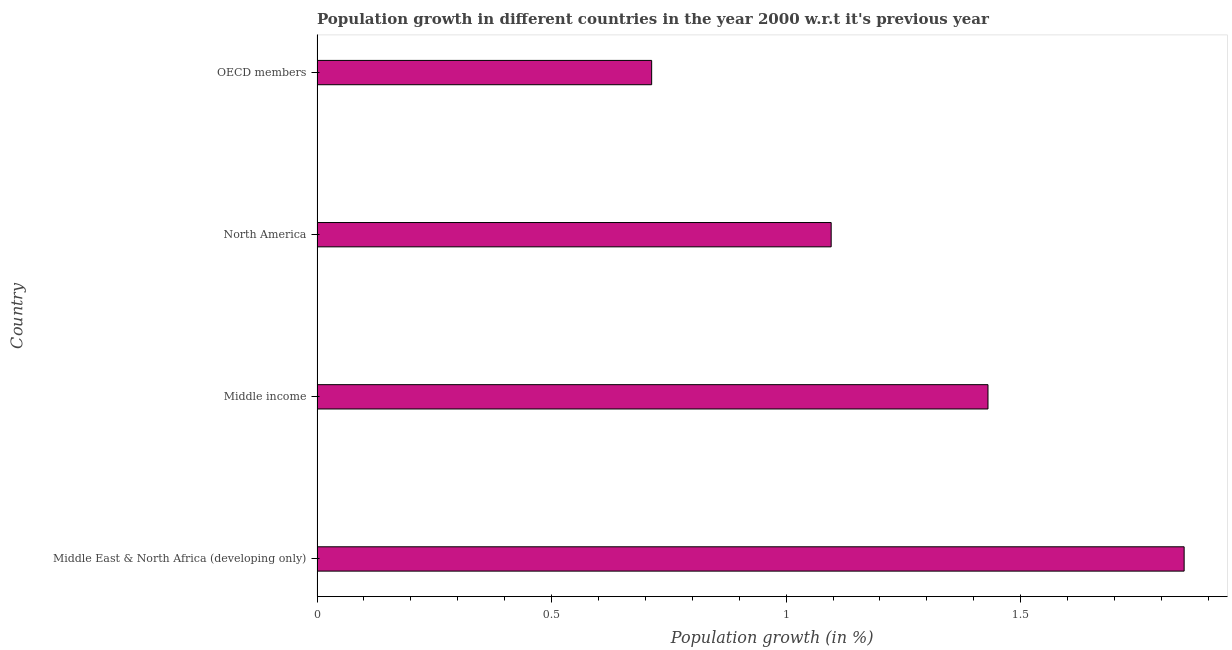Does the graph contain any zero values?
Your response must be concise. No. Does the graph contain grids?
Your answer should be compact. No. What is the title of the graph?
Keep it short and to the point. Population growth in different countries in the year 2000 w.r.t it's previous year. What is the label or title of the X-axis?
Offer a terse response. Population growth (in %). What is the population growth in Middle East & North Africa (developing only)?
Your response must be concise. 1.85. Across all countries, what is the maximum population growth?
Your response must be concise. 1.85. Across all countries, what is the minimum population growth?
Your answer should be compact. 0.71. In which country was the population growth maximum?
Offer a terse response. Middle East & North Africa (developing only). What is the sum of the population growth?
Make the answer very short. 5.09. What is the difference between the population growth in Middle East & North Africa (developing only) and Middle income?
Provide a short and direct response. 0.42. What is the average population growth per country?
Provide a short and direct response. 1.27. What is the median population growth?
Your response must be concise. 1.26. In how many countries, is the population growth greater than 0.1 %?
Keep it short and to the point. 4. What is the ratio of the population growth in Middle East & North Africa (developing only) to that in Middle income?
Offer a very short reply. 1.29. Is the population growth in North America less than that in OECD members?
Give a very brief answer. No. Is the difference between the population growth in Middle East & North Africa (developing only) and North America greater than the difference between any two countries?
Make the answer very short. No. What is the difference between the highest and the second highest population growth?
Your response must be concise. 0.42. Is the sum of the population growth in Middle East & North Africa (developing only) and Middle income greater than the maximum population growth across all countries?
Keep it short and to the point. Yes. What is the difference between the highest and the lowest population growth?
Provide a succinct answer. 1.14. How many countries are there in the graph?
Your response must be concise. 4. What is the difference between two consecutive major ticks on the X-axis?
Your answer should be very brief. 0.5. What is the Population growth (in %) in Middle East & North Africa (developing only)?
Your response must be concise. 1.85. What is the Population growth (in %) of Middle income?
Make the answer very short. 1.43. What is the Population growth (in %) in North America?
Make the answer very short. 1.1. What is the Population growth (in %) of OECD members?
Give a very brief answer. 0.71. What is the difference between the Population growth (in %) in Middle East & North Africa (developing only) and Middle income?
Your response must be concise. 0.42. What is the difference between the Population growth (in %) in Middle East & North Africa (developing only) and North America?
Make the answer very short. 0.75. What is the difference between the Population growth (in %) in Middle East & North Africa (developing only) and OECD members?
Offer a terse response. 1.14. What is the difference between the Population growth (in %) in Middle income and North America?
Keep it short and to the point. 0.33. What is the difference between the Population growth (in %) in Middle income and OECD members?
Provide a short and direct response. 0.72. What is the difference between the Population growth (in %) in North America and OECD members?
Your response must be concise. 0.38. What is the ratio of the Population growth (in %) in Middle East & North Africa (developing only) to that in Middle income?
Your answer should be compact. 1.29. What is the ratio of the Population growth (in %) in Middle East & North Africa (developing only) to that in North America?
Your response must be concise. 1.69. What is the ratio of the Population growth (in %) in Middle East & North Africa (developing only) to that in OECD members?
Provide a succinct answer. 2.59. What is the ratio of the Population growth (in %) in Middle income to that in North America?
Provide a short and direct response. 1.3. What is the ratio of the Population growth (in %) in Middle income to that in OECD members?
Offer a very short reply. 2. What is the ratio of the Population growth (in %) in North America to that in OECD members?
Keep it short and to the point. 1.54. 